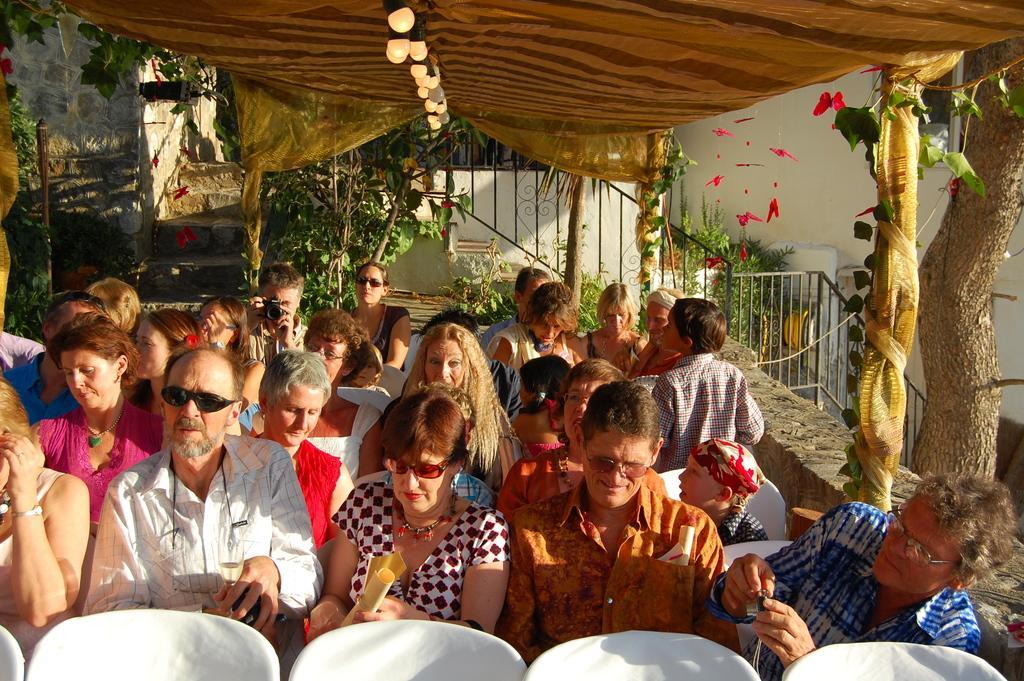Please provide a concise description of this image. In this image we can see people sitting. At the bottom there are chairs. In the background there are trees, stairs, plants, lights and a tent and there is a railing. 